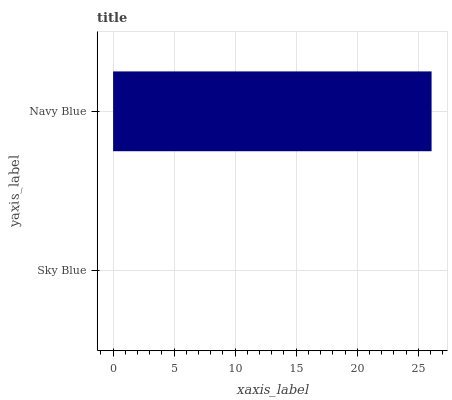Is Sky Blue the minimum?
Answer yes or no. Yes. Is Navy Blue the maximum?
Answer yes or no. Yes. Is Navy Blue the minimum?
Answer yes or no. No. Is Navy Blue greater than Sky Blue?
Answer yes or no. Yes. Is Sky Blue less than Navy Blue?
Answer yes or no. Yes. Is Sky Blue greater than Navy Blue?
Answer yes or no. No. Is Navy Blue less than Sky Blue?
Answer yes or no. No. Is Navy Blue the high median?
Answer yes or no. Yes. Is Sky Blue the low median?
Answer yes or no. Yes. Is Sky Blue the high median?
Answer yes or no. No. Is Navy Blue the low median?
Answer yes or no. No. 